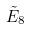<formula> <loc_0><loc_0><loc_500><loc_500>\tilde { E } _ { 8 }</formula> 